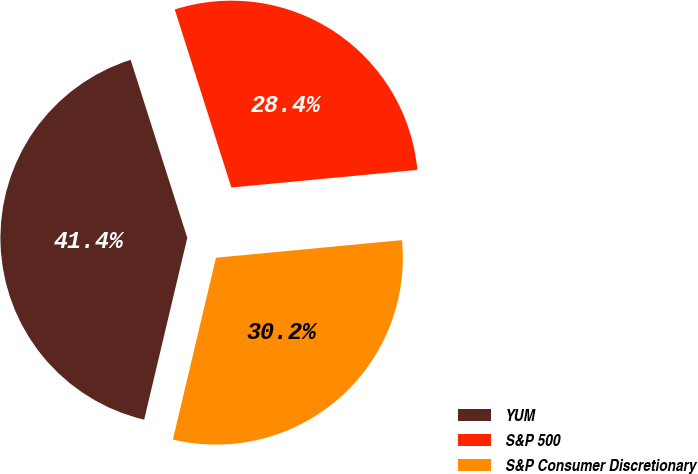Convert chart. <chart><loc_0><loc_0><loc_500><loc_500><pie_chart><fcel>YUM<fcel>S&P 500<fcel>S&P Consumer Discretionary<nl><fcel>41.39%<fcel>28.4%<fcel>30.21%<nl></chart> 